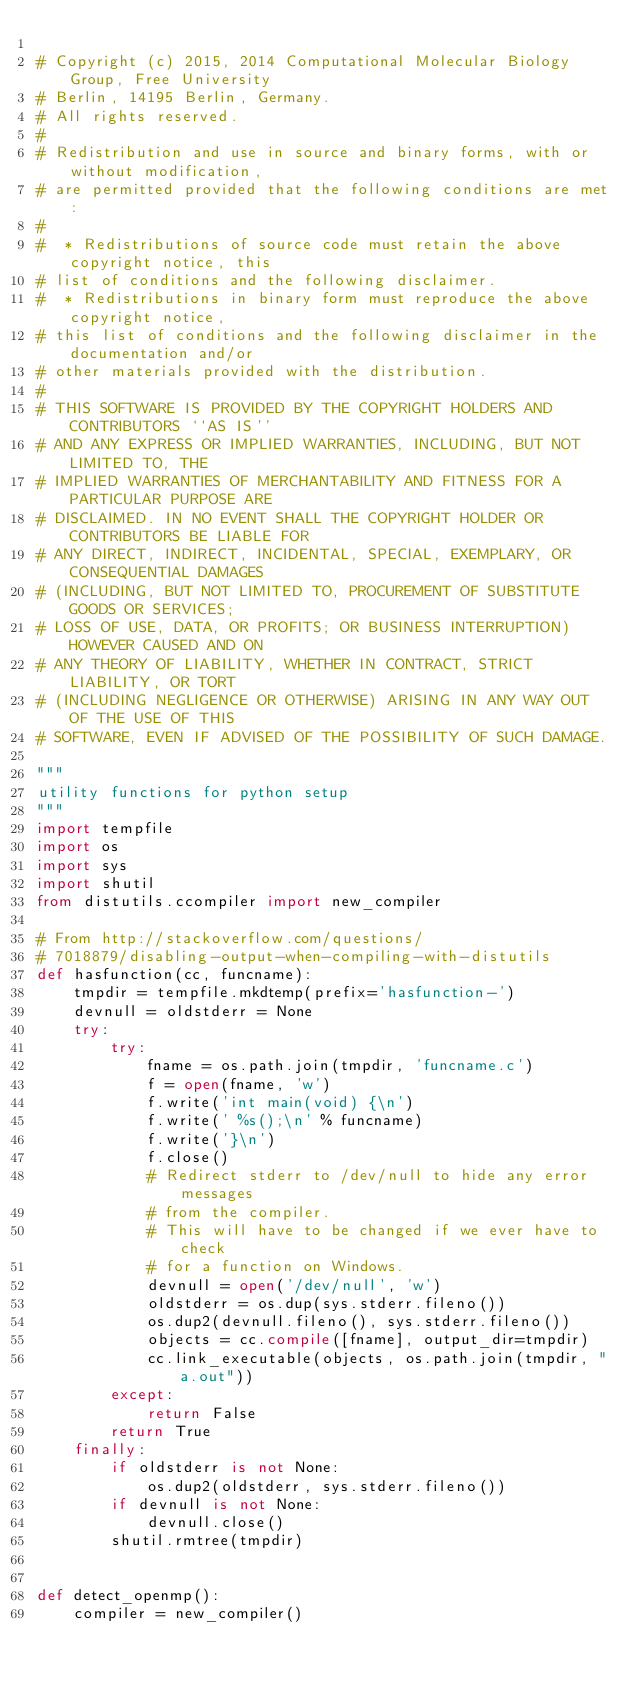Convert code to text. <code><loc_0><loc_0><loc_500><loc_500><_Python_>
# Copyright (c) 2015, 2014 Computational Molecular Biology Group, Free University
# Berlin, 14195 Berlin, Germany.
# All rights reserved.
#
# Redistribution and use in source and binary forms, with or without modification,
# are permitted provided that the following conditions are met:
#
#  * Redistributions of source code must retain the above copyright notice, this
# list of conditions and the following disclaimer.
#  * Redistributions in binary form must reproduce the above copyright notice,
# this list of conditions and the following disclaimer in the documentation and/or
# other materials provided with the distribution.
#
# THIS SOFTWARE IS PROVIDED BY THE COPYRIGHT HOLDERS AND CONTRIBUTORS ``AS IS''
# AND ANY EXPRESS OR IMPLIED WARRANTIES, INCLUDING, BUT NOT LIMITED TO, THE
# IMPLIED WARRANTIES OF MERCHANTABILITY AND FITNESS FOR A PARTICULAR PURPOSE ARE
# DISCLAIMED. IN NO EVENT SHALL THE COPYRIGHT HOLDER OR CONTRIBUTORS BE LIABLE FOR
# ANY DIRECT, INDIRECT, INCIDENTAL, SPECIAL, EXEMPLARY, OR CONSEQUENTIAL DAMAGES
# (INCLUDING, BUT NOT LIMITED TO, PROCUREMENT OF SUBSTITUTE GOODS OR SERVICES;
# LOSS OF USE, DATA, OR PROFITS; OR BUSINESS INTERRUPTION) HOWEVER CAUSED AND ON
# ANY THEORY OF LIABILITY, WHETHER IN CONTRACT, STRICT LIABILITY, OR TORT
# (INCLUDING NEGLIGENCE OR OTHERWISE) ARISING IN ANY WAY OUT OF THE USE OF THIS
# SOFTWARE, EVEN IF ADVISED OF THE POSSIBILITY OF SUCH DAMAGE.

"""
utility functions for python setup
"""
import tempfile
import os
import sys
import shutil
from distutils.ccompiler import new_compiler

# From http://stackoverflow.com/questions/
# 7018879/disabling-output-when-compiling-with-distutils
def hasfunction(cc, funcname):
    tmpdir = tempfile.mkdtemp(prefix='hasfunction-')
    devnull = oldstderr = None
    try:
        try:
            fname = os.path.join(tmpdir, 'funcname.c')
            f = open(fname, 'w')
            f.write('int main(void) {\n')
            f.write(' %s();\n' % funcname)
            f.write('}\n')
            f.close()
            # Redirect stderr to /dev/null to hide any error messages
            # from the compiler.
            # This will have to be changed if we ever have to check
            # for a function on Windows.
            devnull = open('/dev/null', 'w')
            oldstderr = os.dup(sys.stderr.fileno())
            os.dup2(devnull.fileno(), sys.stderr.fileno())
            objects = cc.compile([fname], output_dir=tmpdir)
            cc.link_executable(objects, os.path.join(tmpdir, "a.out"))
        except:
            return False
        return True
    finally:
        if oldstderr is not None:
            os.dup2(oldstderr, sys.stderr.fileno())
        if devnull is not None:
            devnull.close()
        shutil.rmtree(tmpdir)


def detect_openmp():
    compiler = new_compiler()</code> 